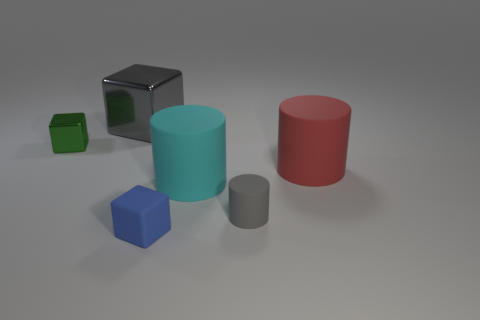Add 3 large green blocks. How many objects exist? 9 Add 3 cyan shiny cylinders. How many cyan shiny cylinders exist? 3 Subtract 0 blue spheres. How many objects are left? 6 Subtract all gray metallic cubes. Subtract all big gray shiny blocks. How many objects are left? 4 Add 3 large gray metal objects. How many large gray metal objects are left? 4 